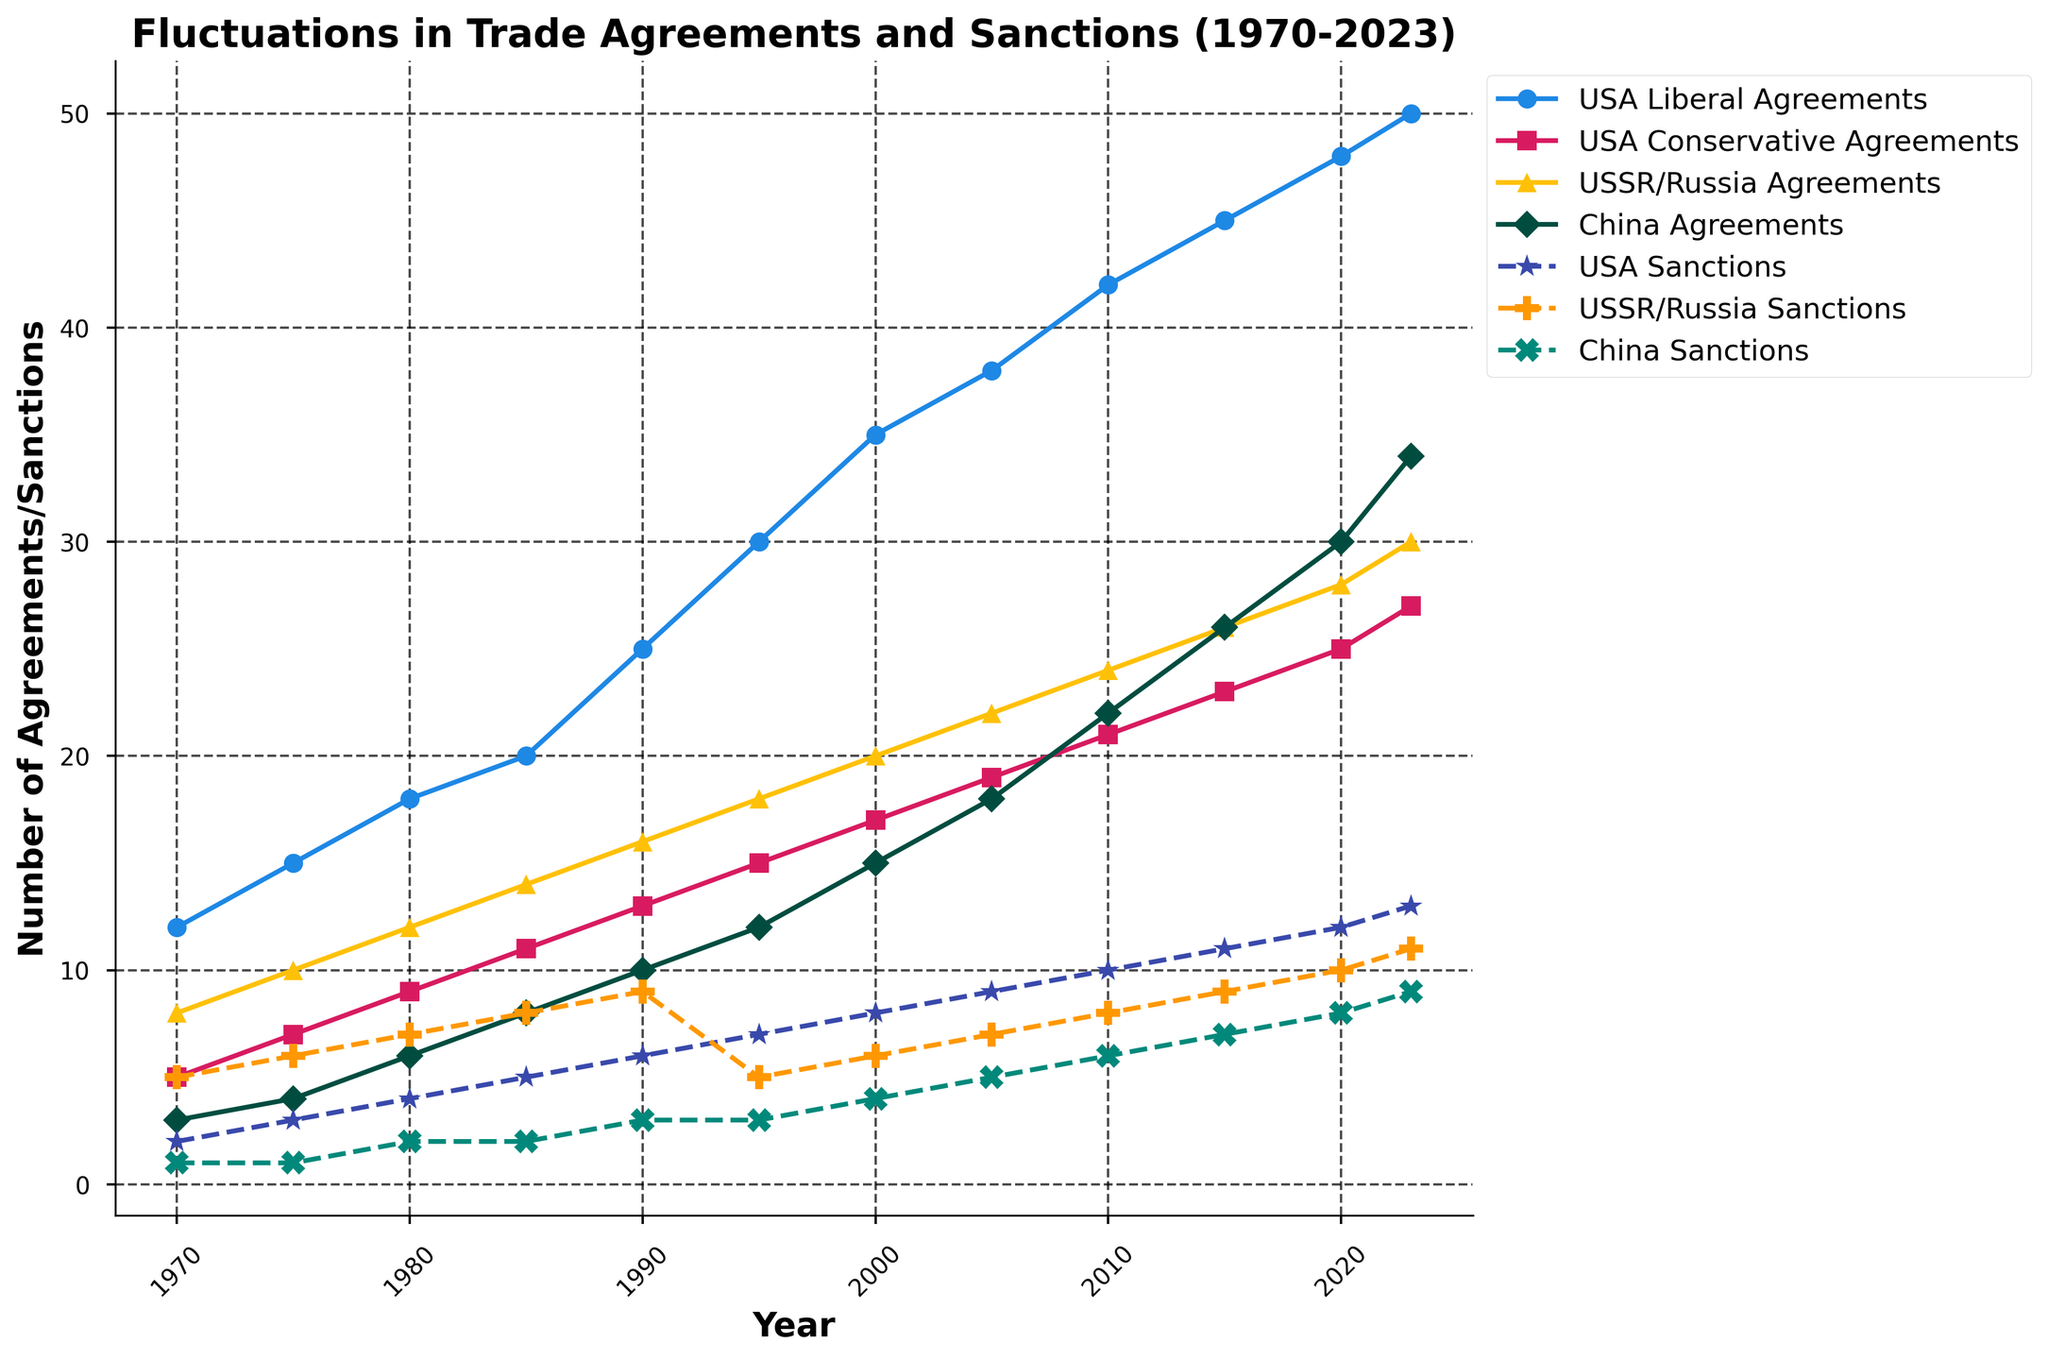What's the trend of USA Liberal Agreements from 1970 to 2023? The line for USA Liberal Agreements shows a consistent increase from 12 in 1970 to 50 in 2023. This indicates a general upward trend in the number of liberal trade agreements made by the USA.
Answer: Increasing How do the USA's Conservative Agreements compare to its Liberal Agreements in 2023? In 2023, the number of USA Liberal Agreements is 50, while the number of USA Conservative Agreements is 27. The liberal agreements are nearly double the conservative ones.
Answer: Liberal Agreements are higher Which country has the most consistent increase in trade agreements from 1970 to 2023? The USA Liberal Agreements line shows a steady and consistent increase from 12 in 1970 to 50 in 2023, indicating the most consistent growth among the countries.
Answer: USA Liberal Agreements What is the difference in the number of sanctions imposed by the USA between 1970 and 2023? In 1970, the USA imposed 2 sanctions, whereas in 2023, it imposed 13 sanctions. The difference is 13 - 2 = 11.
Answer: 11 Between 1990 and 2023, which country showed the highest increase in the number of trade agreements? The USA Liberal Agreements increased from 25 in 1990 to 50 in 2023. This is an increase of 25 agreements, the highest among the countries listed.
Answer: USA Which year did the USSR/Russia impose the highest number of sanctions and how many were there? In 1990, the USSR/Russia imposed 9 sanctions, the highest number across the years displayed.
Answer: 1990 How does the number of sanctions imposed by China in 2023 compare to the number imposed by the USA in 1970? China imposed 9 sanctions in 2023, while the USA imposed 2 sanctions in 1970. China imposed 7 more sanctions than the USA did in 1970.
Answer: China imposed more What is the average number of trade agreements made by China from 1970 to 2023? The total number of trade agreements made by China from 1970 to 2023 is the sum of the values (3 + 4 + 6 + 8 + 10 + 12 + 15 + 18 + 22 + 26 + 30 + 34) = 188. There are 12 years, so the average is 188/12 ≈ 15.67.
Answer: 15.67 What visual pattern do you observe in the plot for USA Sanctions over the years? The USA Sanctions line shows a consistent increase over the years, represented by a dashed line with star markers and rising from 2 in 1970 to 13 in 2023.
Answer: Consistent increase How does the number of trade agreements made by the USA in 2000 compare to those made by China in the same year? In 2000, the USA Liberal Agreements were 35, and the USA Conservative Agreements were 17, so total USA agreements were 35 + 17 = 52. China had 15 agreements. Hence, the USA had significantly more agreements.
Answer: USA had more agreements 